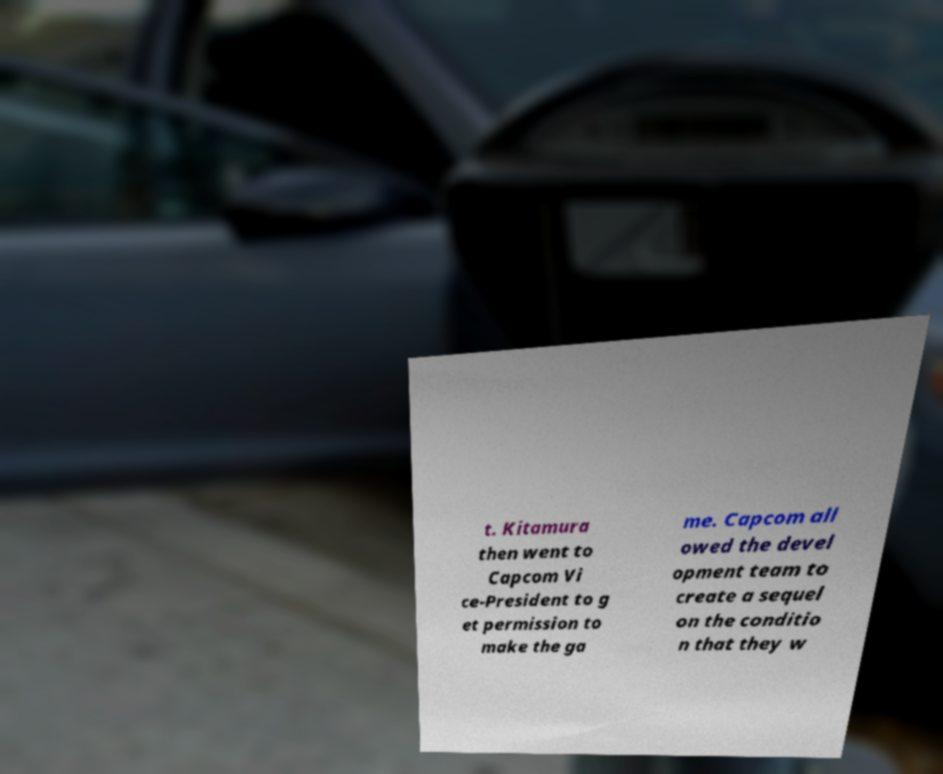For documentation purposes, I need the text within this image transcribed. Could you provide that? t. Kitamura then went to Capcom Vi ce-President to g et permission to make the ga me. Capcom all owed the devel opment team to create a sequel on the conditio n that they w 